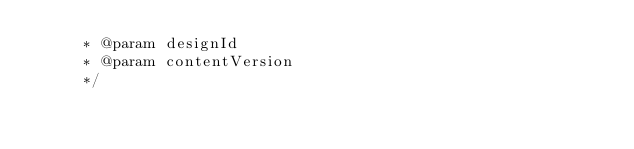Convert code to text. <code><loc_0><loc_0><loc_500><loc_500><_Java_>     * @param designId
     * @param contentVersion
     */</code> 